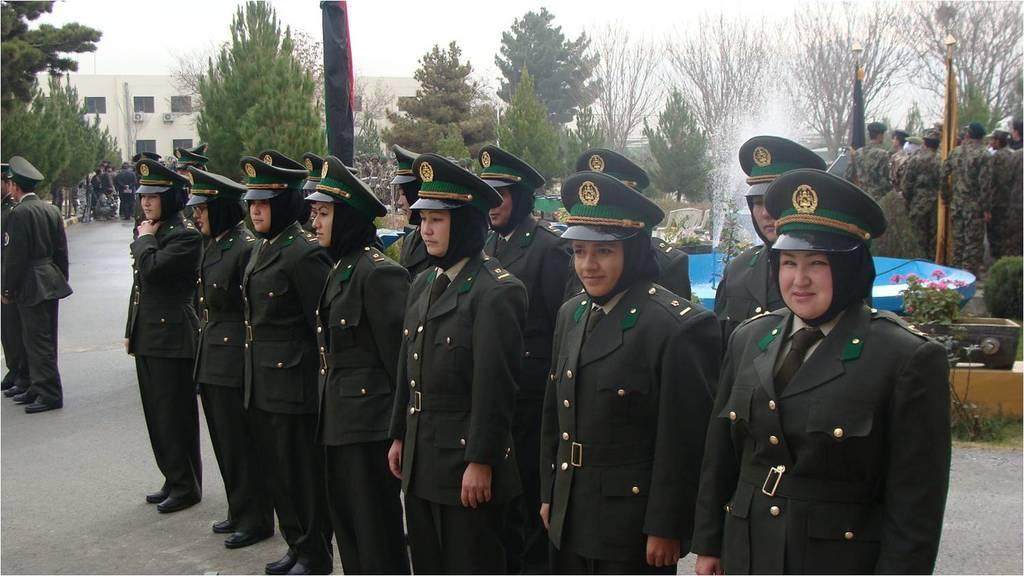In one or two sentences, can you explain what this image depicts? In the center of the image we can see a few people are standing and they are in different costumes. Among them, we can see a few people are smiling. In the background, we can see the sky, clouds, trees, plants, poles, benches, one building, fountain, few people are standing and a few other objects. 